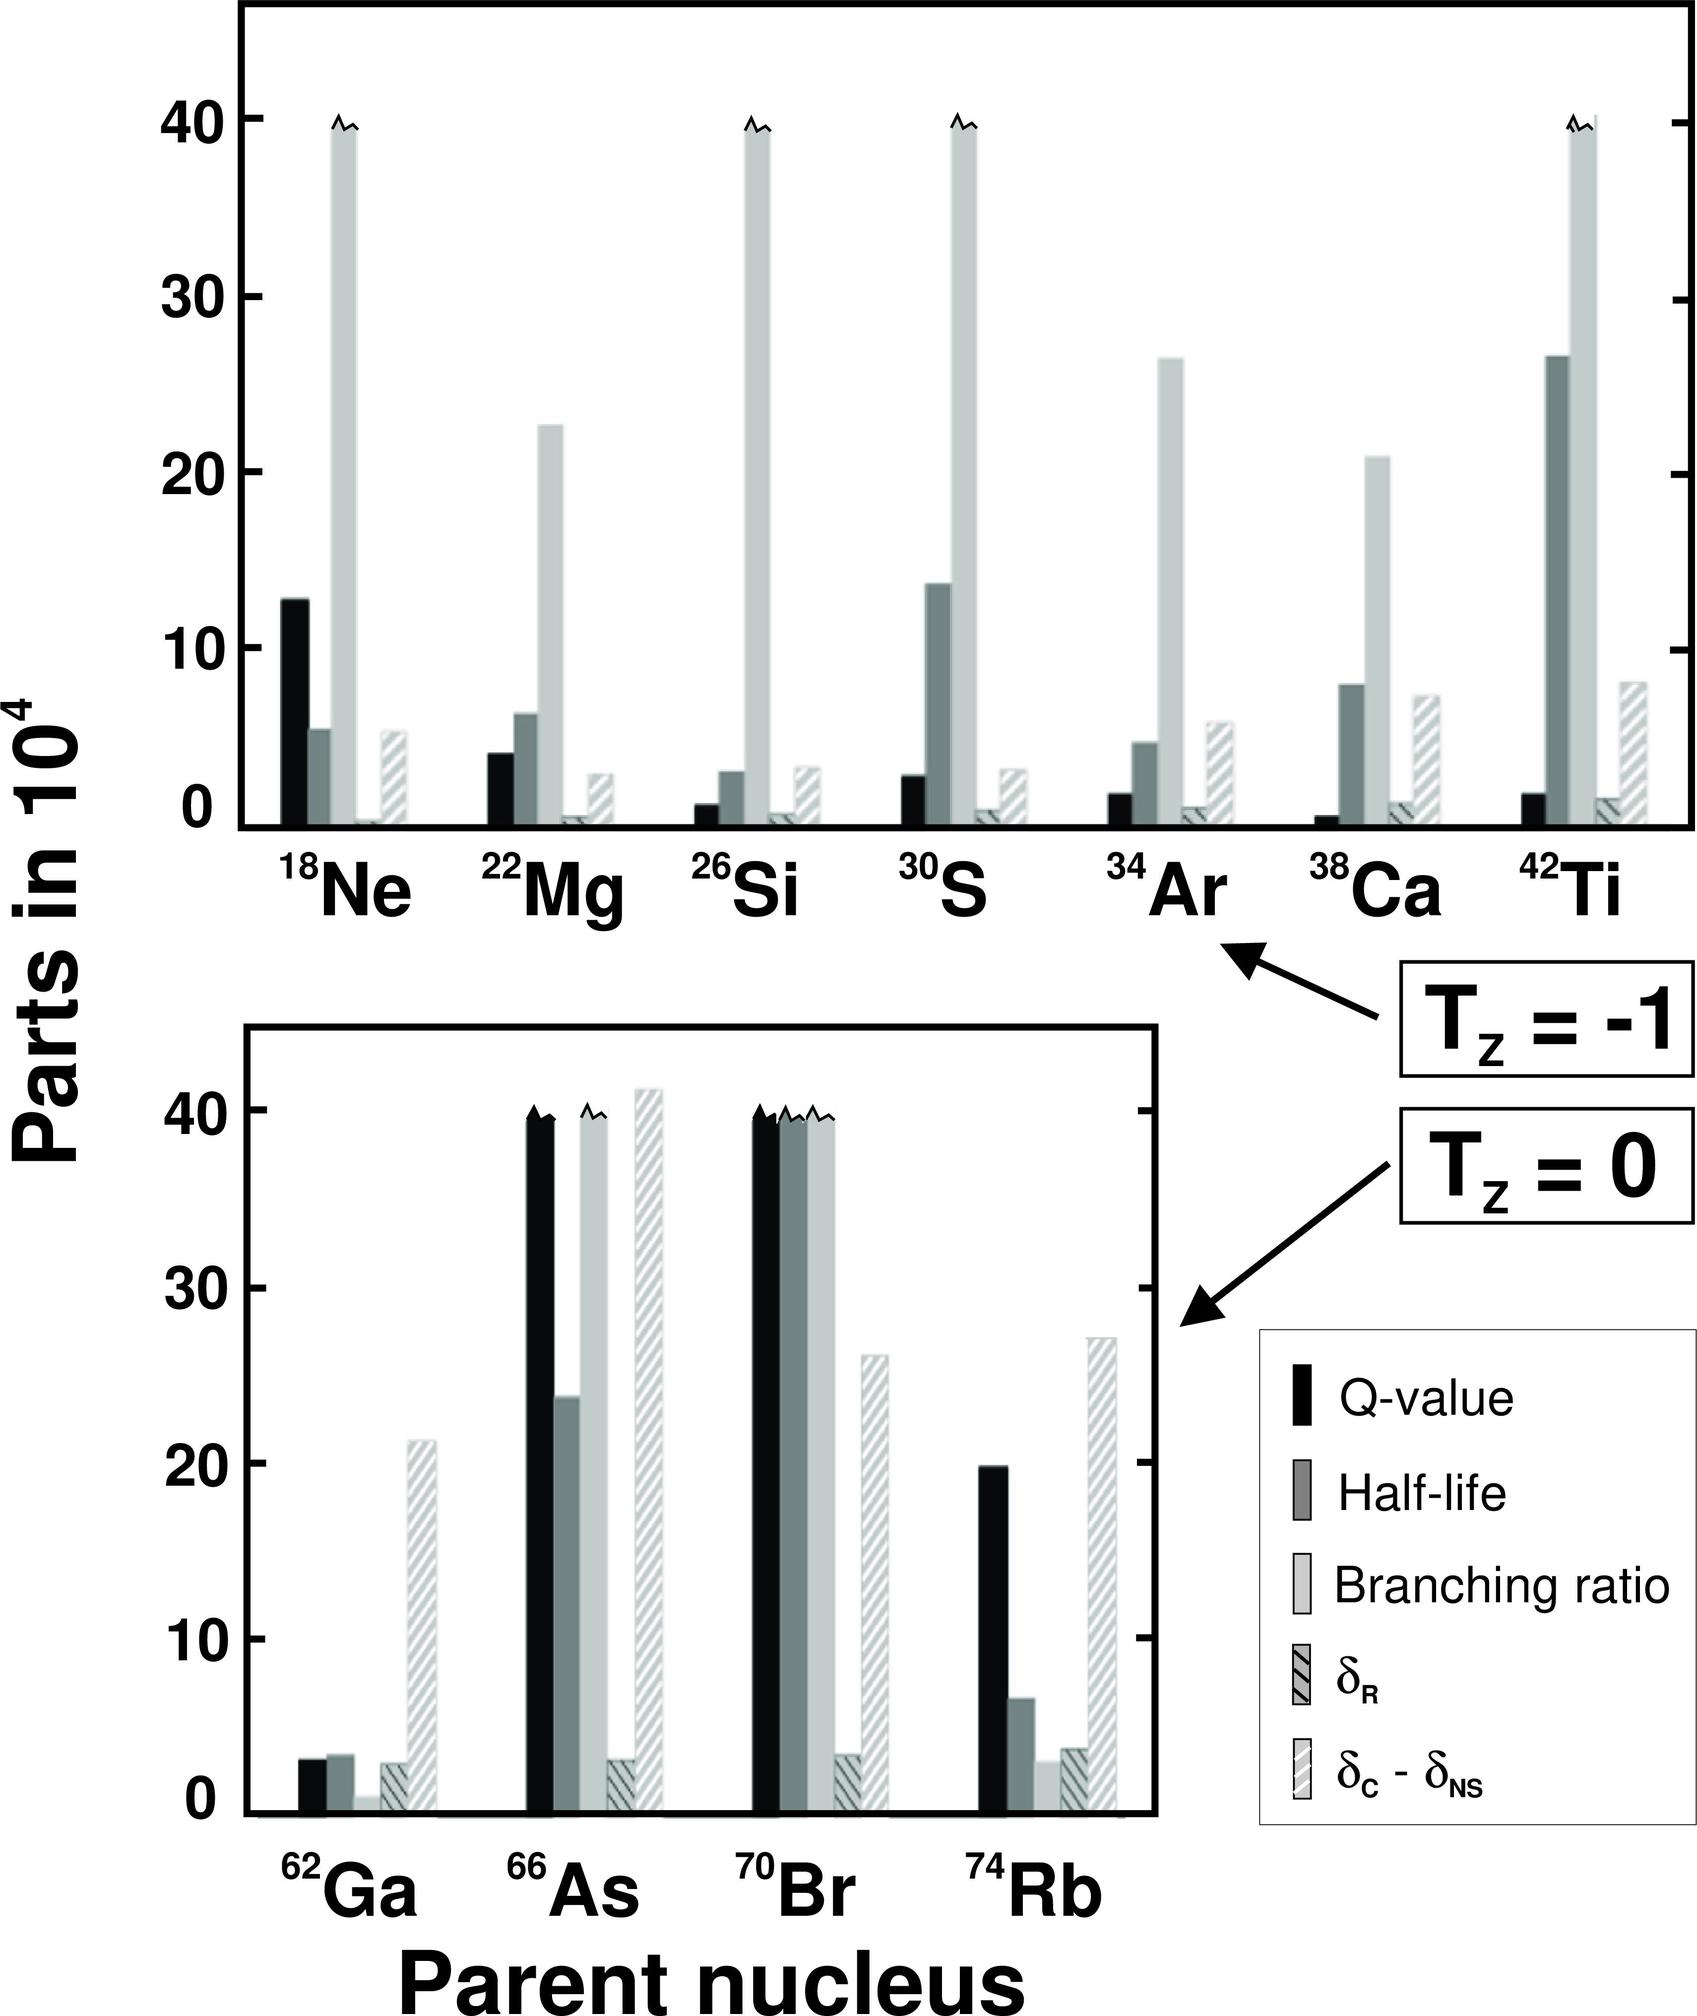What do the different shades and patterns in the bars represent? The graph uses various shading patterns to represent different properties associated with the parent nuclei. The solid black bars indicate the Q-value, which is the energy released during decay. The dark grey bars show the half-life of the isotopes, which is the time taken for half the amount of a radioactive substance to decay. The lighter grey bars with a pattern signify the branching ratio, which is the fraction of a decay process that follows a particular pathway. Lastly, the crosshatching and shaded bars without black at the bottom indicate \( \delta_R \) and \( \delta_C - \delta_{NS} \), respectively, which are related to the changes in decay energy due to pairing and shape effects. 